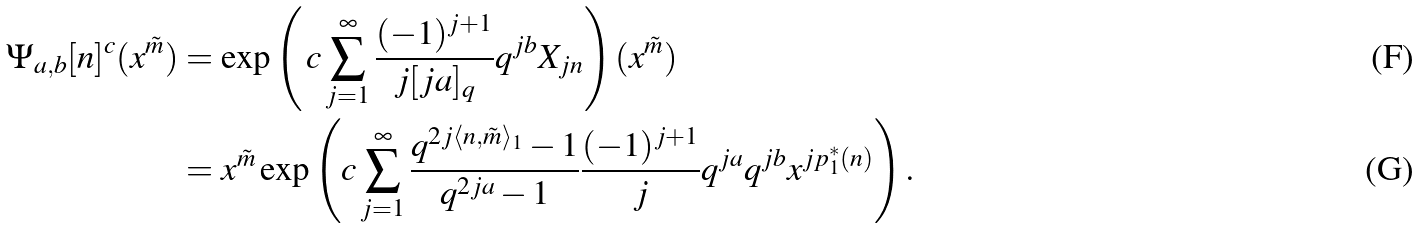Convert formula to latex. <formula><loc_0><loc_0><loc_500><loc_500>\Psi _ { a , b } [ n ] ^ { c } ( x ^ { \tilde { m } } ) & = \exp \left ( \, c \sum _ { j = 1 } ^ { \infty } \frac { ( - 1 ) ^ { j + 1 } } { j [ j a ] _ { q } } q ^ { j b } X _ { j n } \right ) ( x ^ { \tilde { m } } ) \\ & = x ^ { \tilde { m } } \exp \left ( c \sum _ { j = 1 } ^ { \infty } \frac { q ^ { 2 j \langle n , \tilde { m } \rangle _ { 1 } } - 1 } { q ^ { 2 j a } - 1 } \frac { ( - 1 ) ^ { j + 1 } } { j } q ^ { j a } q ^ { j b } x ^ { j p _ { 1 } ^ { * } ( n ) } \right ) .</formula> 